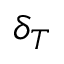<formula> <loc_0><loc_0><loc_500><loc_500>\delta _ { T }</formula> 